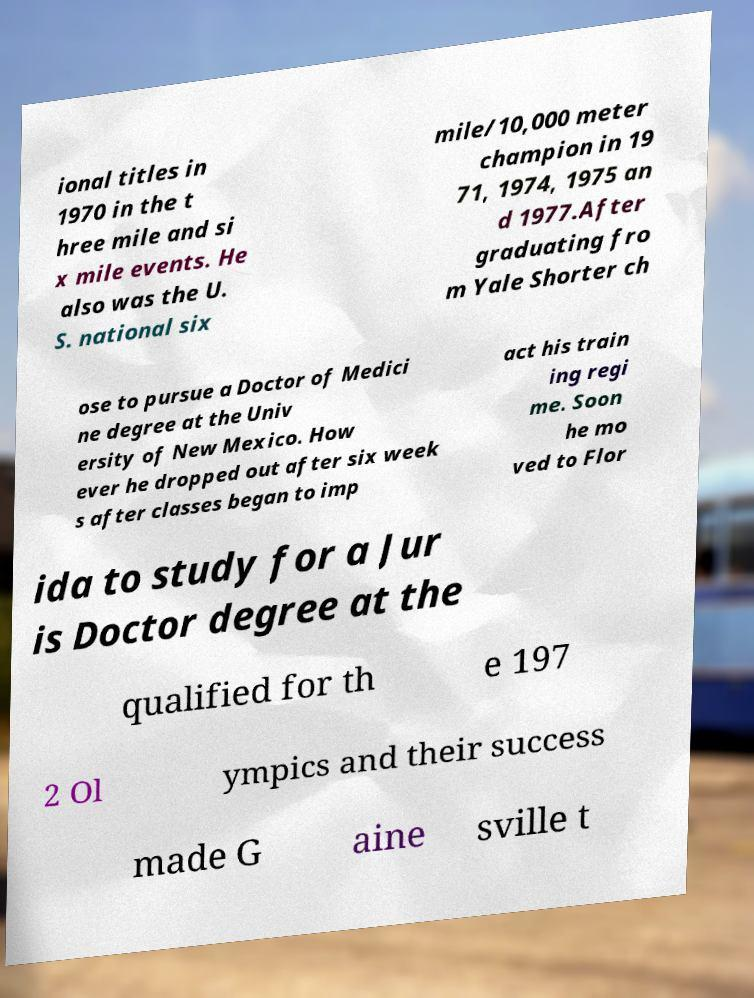For documentation purposes, I need the text within this image transcribed. Could you provide that? ional titles in 1970 in the t hree mile and si x mile events. He also was the U. S. national six mile/10,000 meter champion in 19 71, 1974, 1975 an d 1977.After graduating fro m Yale Shorter ch ose to pursue a Doctor of Medici ne degree at the Univ ersity of New Mexico. How ever he dropped out after six week s after classes began to imp act his train ing regi me. Soon he mo ved to Flor ida to study for a Jur is Doctor degree at the qualified for th e 197 2 Ol ympics and their success made G aine sville t 